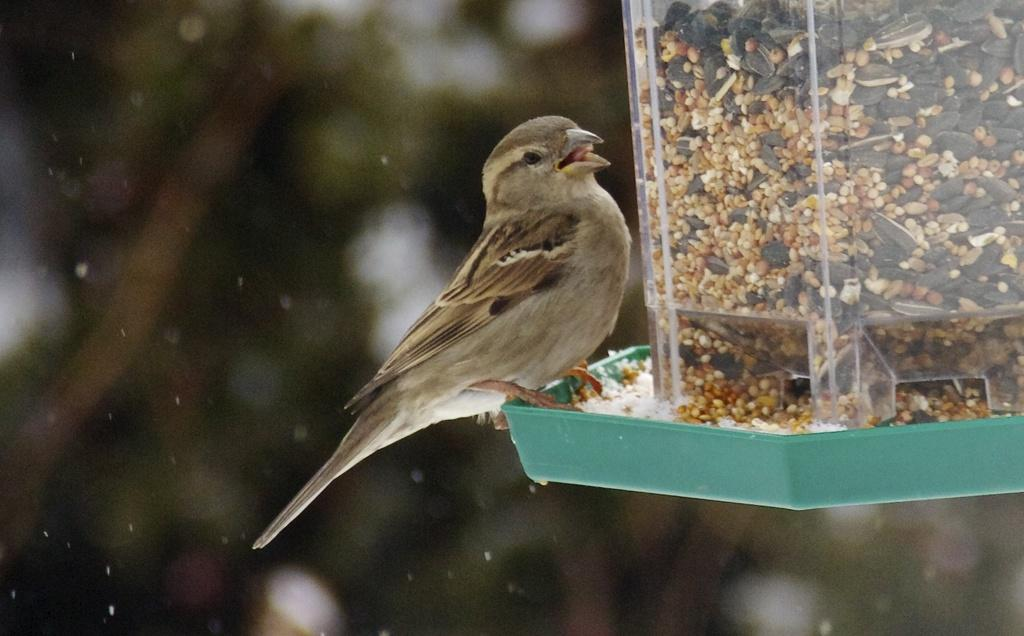What animal can be seen on the right side of the image? There is a bird on the right side of the image. What is the bird standing on? The bird is standing on the edge of a green tray. What is present in the tray with the bird? There is an object with seeds in the tray. Can you describe the background of the image? The background of the image is blurred. Who is the expert on the plantation in the image? There is no expert or plantation present in the image; it features a bird standing on a green tray with seeds. 